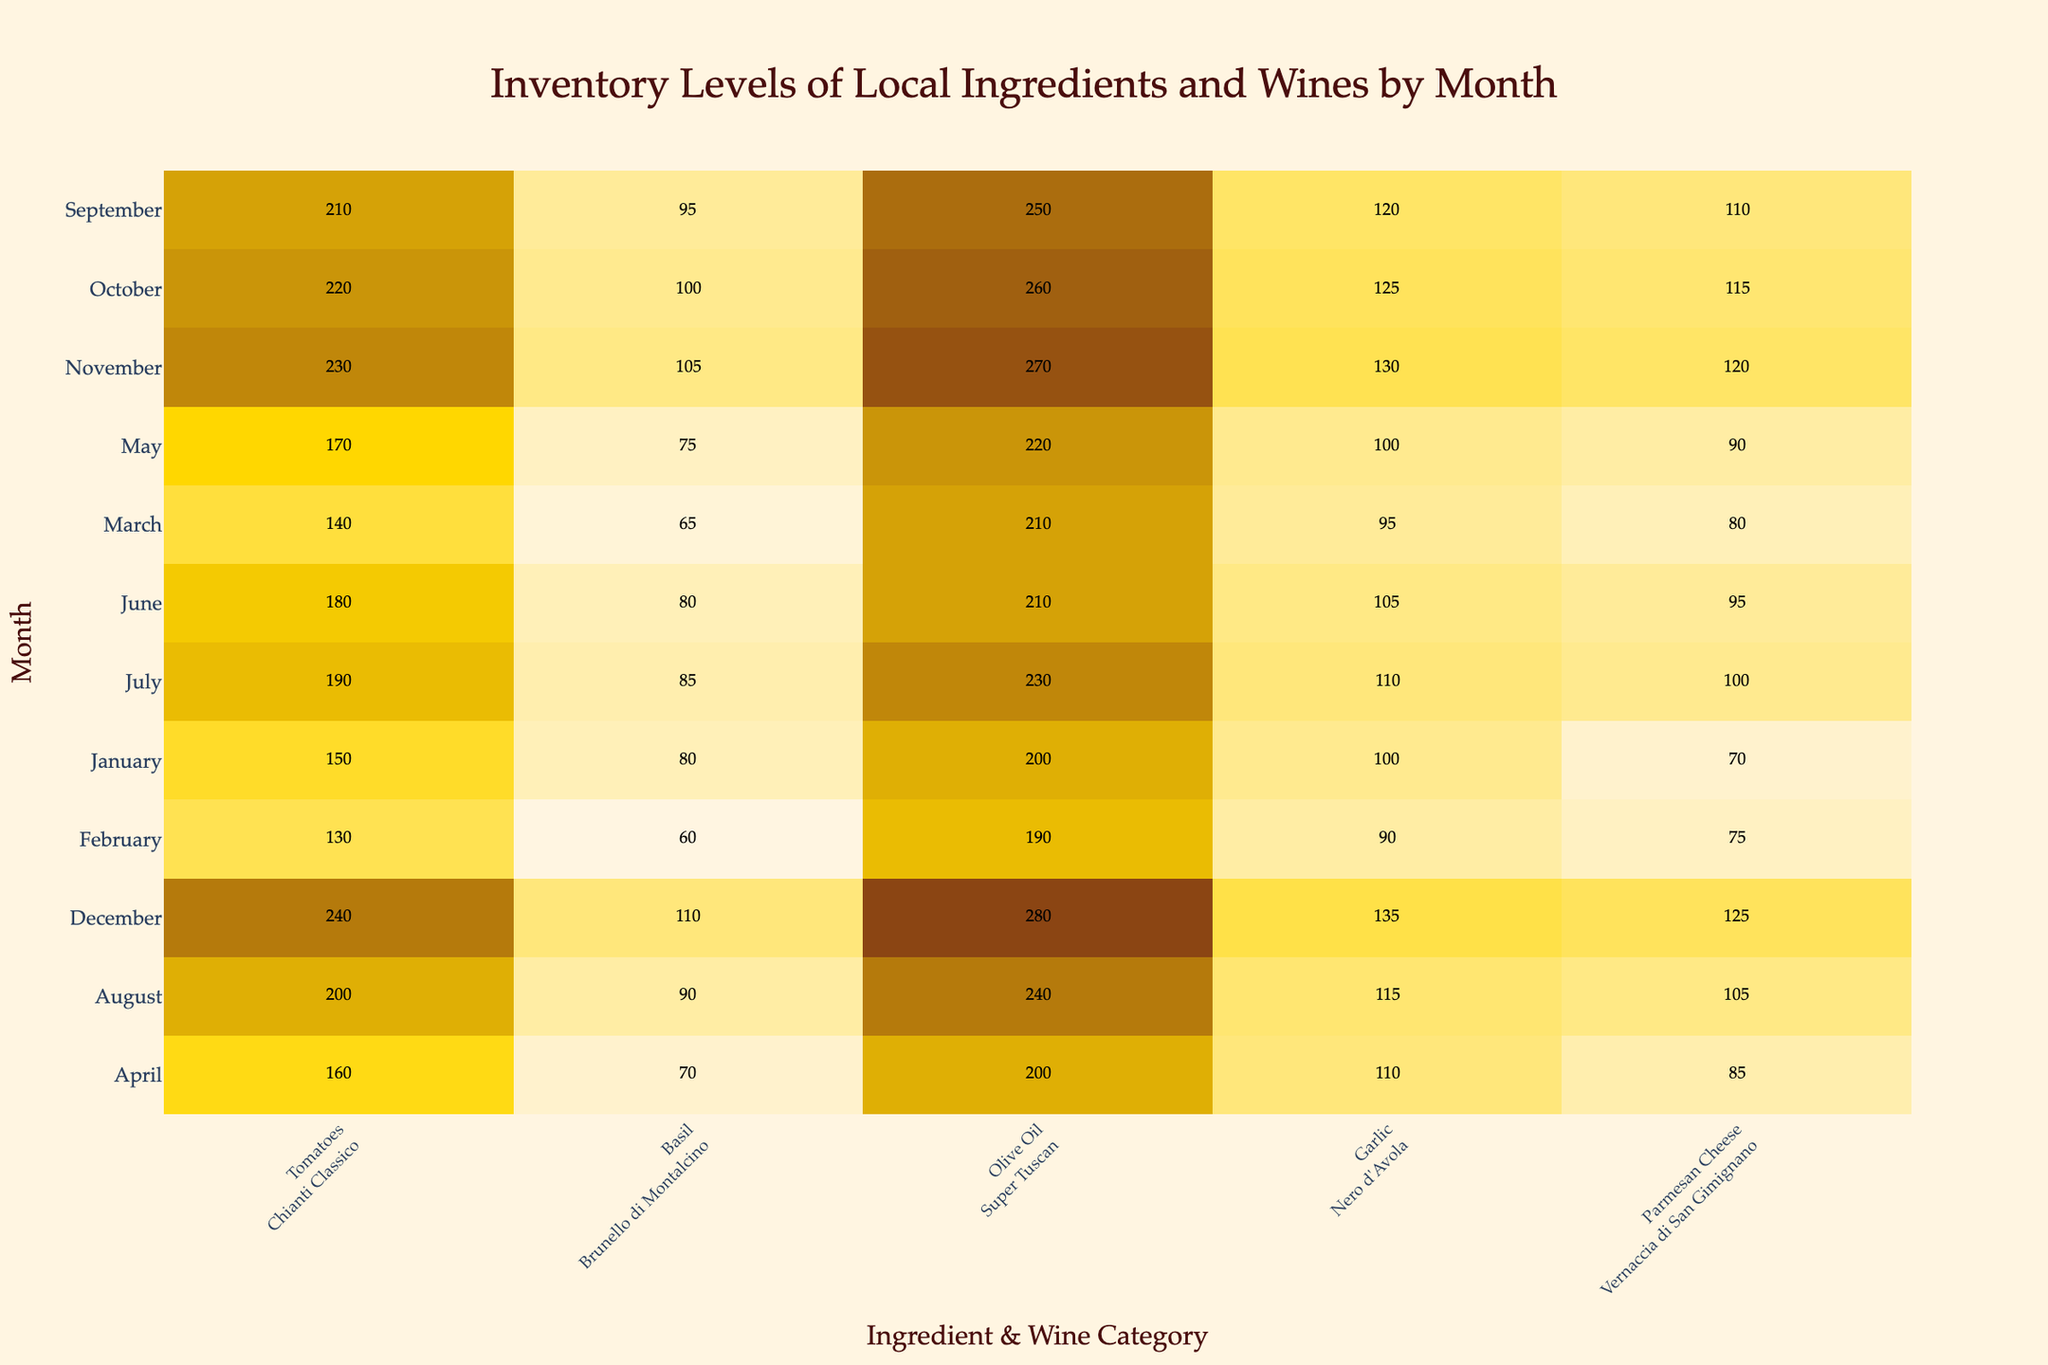What is the inventory level of Tomatoes in August? The table shows that the inventory level of Tomatoes in August is listed as 200 kg.
Answer: 200 kg Which month has the highest inventory level of Olive Oil? Looking at the rows for Olive Oil, December shows the highest value at 280 kg.
Answer: 280 kg Is the inventory level of Garlic consistently increasing each month? By examining the values for Garlic month by month, they are: 100, 90, 95, 110, 100, 105, 110, 115, 120, 125, 130, and 135. This does not show a consistent increase as some values drop in February and May.
Answer: No What is the average inventory level of Basil over the year? The monthly Basil inventory levels are: 80, 60, 65, 70, 75, 80, 85, 90, 95, 100, 105, and 110. Summing these gives: 1,100. There are 12 months, so the average is 1,100 / 12 = 91.67 kg.
Answer: 91.67 kg In which month do we see the lowest inventory of Parmesan Cheese? The Parmesan Cheese values by month are: 70, 75, 80, 85, 90, 95, 100, 105, 110, 115, 120, and 125. The minimum value is 70, which occurs in January.
Answer: January What is the total inventory level of Tomatoes for the first half of the year (January to June)? The total for Tomatoes from January to June is: 150 + 130 + 140 + 160 + 170 + 180 = 1,030 kg.
Answer: 1,030 kg Which wine category has the highest total inventory across all months? By summing the inventory levels for each wine category: Chianti Classico = 1,885 kg, Brunello di Montalcino = 1,050 kg, Super Tuscan = 2,380 kg, Nero d'Avola = 1,245 kg, Vernaccia di San Gimignano = 1,215 kg. Super Tuscan has the highest total inventory.
Answer: Super Tuscan Was there ever a month when the inventory of Basil exceeded 100 kg? By checking the values for Basil, the inventory does exceed 100 kg only in October, November, and December.
Answer: Yes What was the change in inventory level of Garlic from January to December? The January inventory of Garlic was 100 kg, and in December it was 135 kg. The change is 135 - 100 = 35 kg increase.
Answer: 35 kg increase 